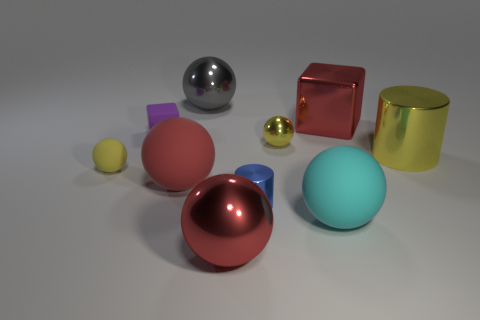What color is the other big shiny thing that is the same shape as the big gray metal object?
Make the answer very short. Red. What is the size of the red matte thing?
Offer a terse response. Large. How many big gray objects have the same shape as the big cyan thing?
Ensure brevity in your answer.  1. Is the color of the small matte cube the same as the small metal sphere?
Your answer should be compact. No. Does the ball behind the large red shiny block have the same color as the tiny rubber sphere?
Offer a terse response. No. What is the shape of the matte thing that is on the right side of the tiny blue object in front of the tiny matte block?
Keep it short and to the point. Sphere. How many things are either yellow things to the right of the big shiny cube or tiny spheres that are right of the big gray sphere?
Offer a very short reply. 2. The small yellow object that is made of the same material as the tiny blue object is what shape?
Offer a very short reply. Sphere. Are there any other things of the same color as the tiny block?
Your answer should be compact. No. There is a red thing that is the same shape as the tiny purple object; what is it made of?
Make the answer very short. Metal. 